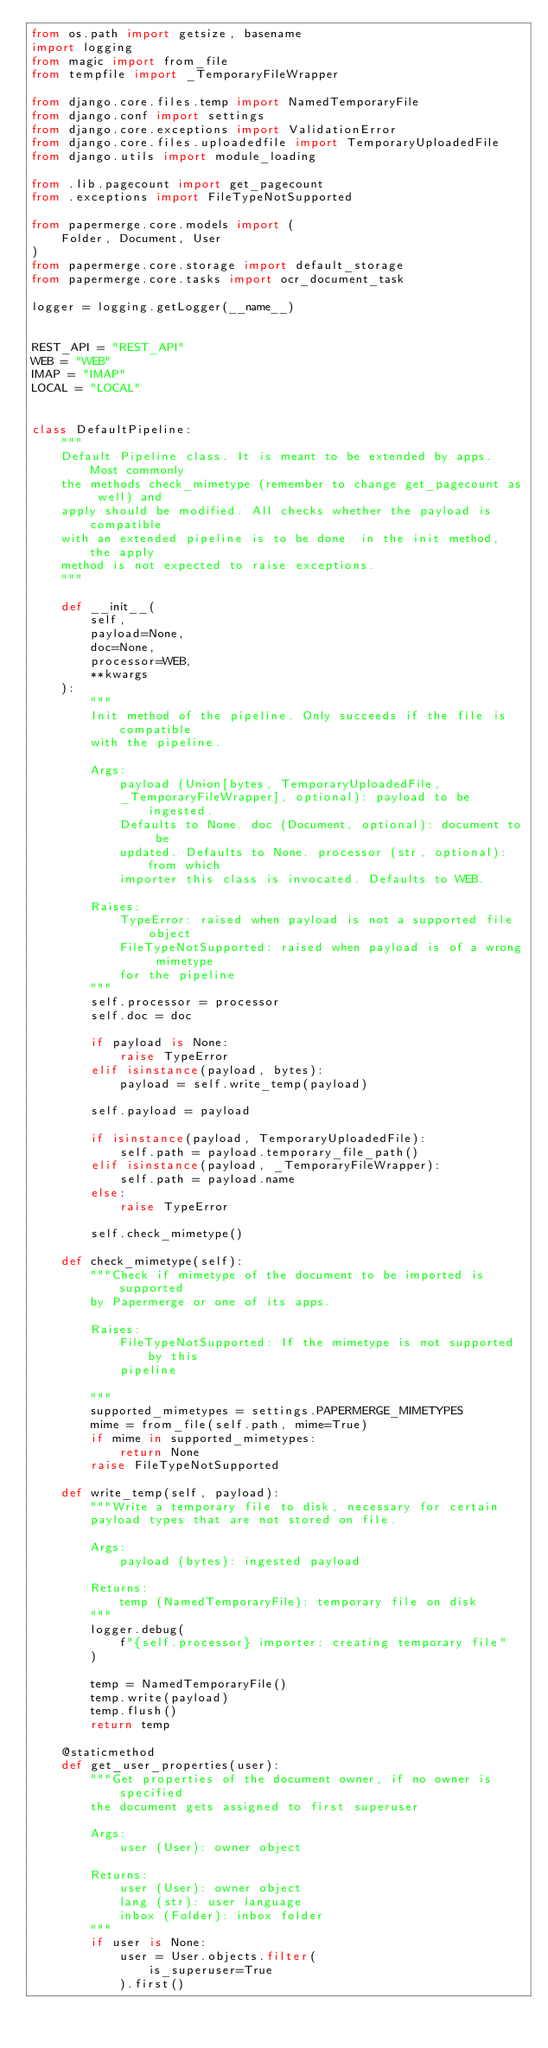<code> <loc_0><loc_0><loc_500><loc_500><_Python_>from os.path import getsize, basename
import logging
from magic import from_file
from tempfile import _TemporaryFileWrapper

from django.core.files.temp import NamedTemporaryFile
from django.conf import settings
from django.core.exceptions import ValidationError
from django.core.files.uploadedfile import TemporaryUploadedFile
from django.utils import module_loading

from .lib.pagecount import get_pagecount
from .exceptions import FileTypeNotSupported

from papermerge.core.models import (
    Folder, Document, User
)
from papermerge.core.storage import default_storage
from papermerge.core.tasks import ocr_document_task

logger = logging.getLogger(__name__)


REST_API = "REST_API"
WEB = "WEB"
IMAP = "IMAP"
LOCAL = "LOCAL"


class DefaultPipeline:
    """
    Default Pipeline class. It is meant to be extended by apps. Most commonly
    the methods check_mimetype (remember to change get_pagecount as well) and
    apply should be modified. All checks whether the payload is compatible
    with an extended pipeline is to be done  in the init method, the apply
    method is not expected to raise exceptions.
    """

    def __init__(
        self,
        payload=None,
        doc=None,
        processor=WEB,
        **kwargs
    ):
        """
        Init method of the pipeline. Only succeeds if the file is compatible
        with the pipeline.

        Args:
            payload (Union[bytes, TemporaryUploadedFile,
            _TemporaryFileWrapper], optional): payload to be ingested.
            Defaults to None. doc (Document, optional): document to be
            updated. Defaults to None. processor (str, optional): from which
            importer this class is invocated. Defaults to WEB.

        Raises:
            TypeError: raised when payload is not a supported file object
            FileTypeNotSupported: raised when payload is of a wrong mimetype
            for the pipeline
        """
        self.processor = processor
        self.doc = doc

        if payload is None:
            raise TypeError
        elif isinstance(payload, bytes):
            payload = self.write_temp(payload)

        self.payload = payload

        if isinstance(payload, TemporaryUploadedFile):
            self.path = payload.temporary_file_path()
        elif isinstance(payload, _TemporaryFileWrapper):
            self.path = payload.name
        else:
            raise TypeError

        self.check_mimetype()

    def check_mimetype(self):
        """Check if mimetype of the document to be imported is supported
        by Papermerge or one of its apps.

        Raises:
            FileTypeNotSupported: If the mimetype is not supported by this
            pipeline

        """
        supported_mimetypes = settings.PAPERMERGE_MIMETYPES
        mime = from_file(self.path, mime=True)
        if mime in supported_mimetypes:
            return None
        raise FileTypeNotSupported

    def write_temp(self, payload):
        """Write a temporary file to disk, necessary for certain
        payload types that are not stored on file.

        Args:
            payload (bytes): ingested payload

        Returns:
            temp (NamedTemporaryFile): temporary file on disk
        """
        logger.debug(
            f"{self.processor} importer: creating temporary file"
        )

        temp = NamedTemporaryFile()
        temp.write(payload)
        temp.flush()
        return temp

    @staticmethod
    def get_user_properties(user):
        """Get properties of the document owner, if no owner is specified
        the document gets assigned to first superuser

        Args:
            user (User): owner object

        Returns:
            user (User): owner object
            lang (str): user language
            inbox (Folder): inbox folder
        """
        if user is None:
            user = User.objects.filter(
                is_superuser=True
            ).first()</code> 